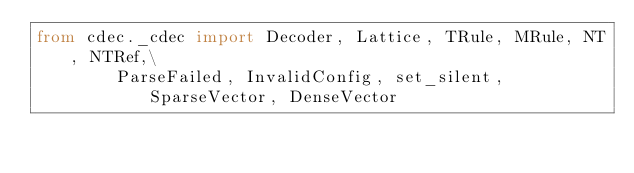Convert code to text. <code><loc_0><loc_0><loc_500><loc_500><_Python_>from cdec._cdec import Decoder, Lattice, TRule, MRule, NT, NTRef,\
        ParseFailed, InvalidConfig, set_silent, SparseVector, DenseVector
</code> 